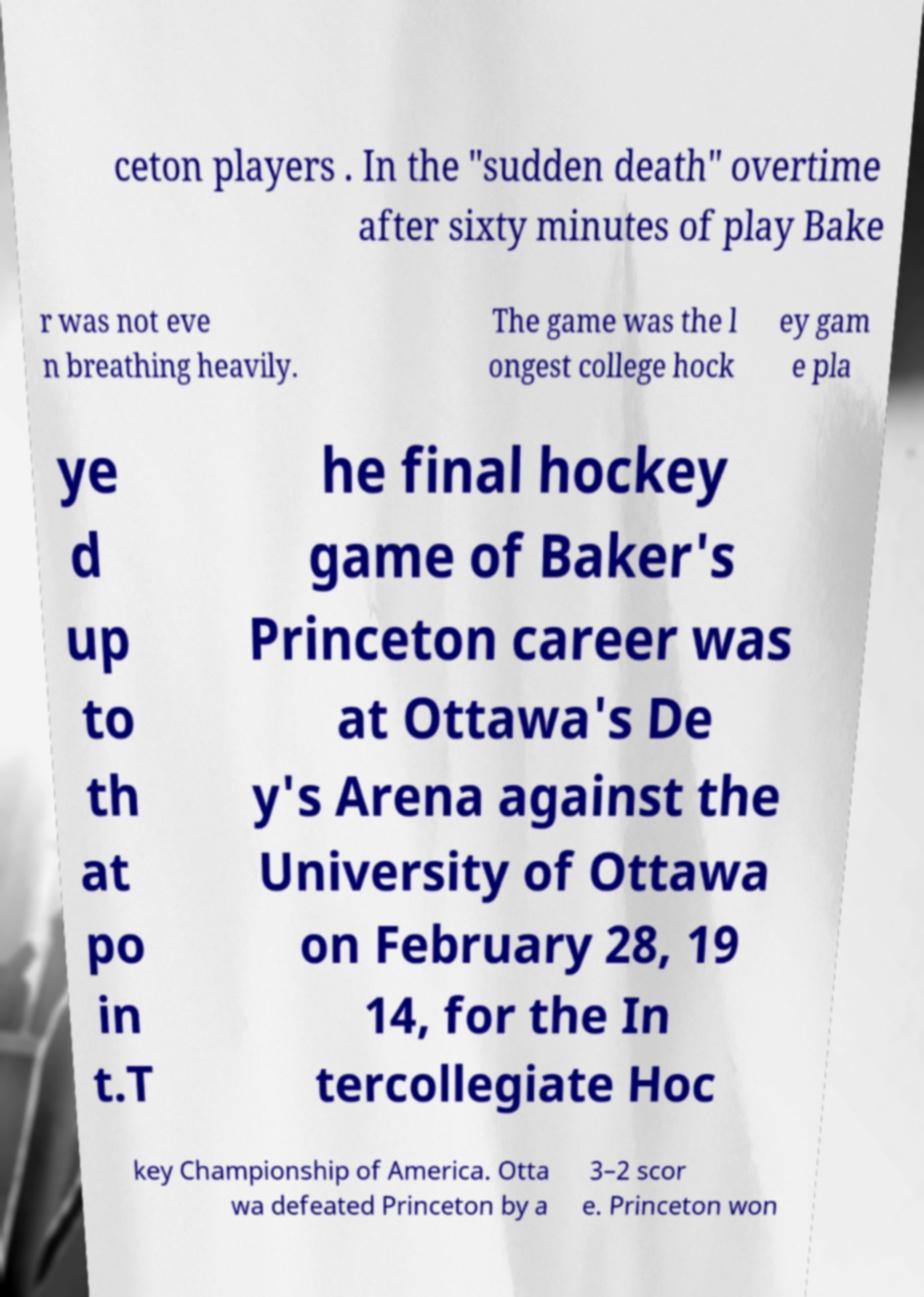Can you accurately transcribe the text from the provided image for me? ceton players . In the "sudden death" overtime after sixty minutes of play Bake r was not eve n breathing heavily. The game was the l ongest college hock ey gam e pla ye d up to th at po in t.T he final hockey game of Baker's Princeton career was at Ottawa's De y's Arena against the University of Ottawa on February 28, 19 14, for the In tercollegiate Hoc key Championship of America. Otta wa defeated Princeton by a 3–2 scor e. Princeton won 